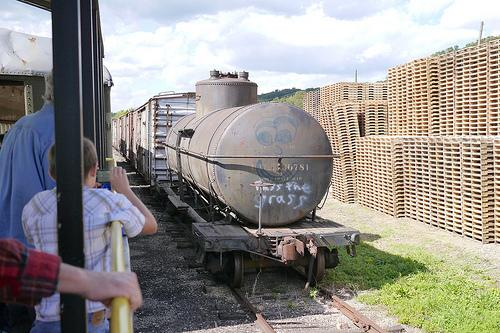Name the type of object located next to the train that is related to storage or material handling. There are stacks of wooden pallets located next to the train. Who is wearing a white and blue plaid shirt in the image? A little boy is wearing a white and blue plaid shirt. Identify the transportation mode present in the image and describe its state. There is a long train on the tracks that looks old and rusty. What are the functions of the yellow items present in the image? The yellow items are handrails for support and safety. In a short sentence or two, describe the overall atmosphere and sentiment of the image. The image conveys an industrial scene with an aging train on the tracks, surrounded by pallets and people observing or photographing it. The vibe is somewhat nostalgic. Describe the condition and type of train car that appears to carry chemicals. The train car for carrying chemicals is a black tanker car, and it looks old and rusty. Identify any artwork or graffiti present on the train cars. There is white graffiti, a smiley face, pass the grass spray paint, and a blue face painted on the train cars. Count the number of people in the image and describe their general appearance and actions. There are four people; a man in a blue shirt, another man taking picture with his cellphone, a kid in a white shirt likely taking a picture as well, and a boy in jeans. What color is the predominant color in the sky? Blue and white, as it appears to be a cloudy sky. Describe the ground near the train tracks. There is a strip of green grass growing along the train tracks. Describe the material of the pole that is blocking the man with the phone. Metal What are the piles of wooden objects near the train? Stacks of wooden pallets What kind of vehicle is occupying most of the image? A train What are the jeans on in the image? A boy What is the color of the sky in the image? Blue and white Describe the expression drawn on the metal tank. A smiley face What is the color of the rusted train tracks? Brownish What activity is being performed by the man in the blue shirt? Watching the train Identify the person wearing a white and blue plaid shirt in the scene. A little boy taking a picture Is the train driving towards the camera with a purple color? The train is actually driving away from the camera, and there is no mention of it being purple. In the image, which person appears to be taking a picture? A kid Are there any animals such as dogs or cats wandering around the scene? No, it's not mentioned in the image. Which person in the image is wearing a blue shirt? A man Who is watching the train in the image? A small group of people What's written on the tanker in white graffiti? Pass the grass What is the graffiti on the front of the train? Blue face and "pass the grass" What is the color of the handrail near the train? Yellow Name an object on the train that shows aging. Rusty boxcar Who is obstructed by a metal pole in the photo? Man taking picture with cell phone What type of train car is rusty white? A boxcar What type of vegetation is found near the railroad tracks? Green grass 